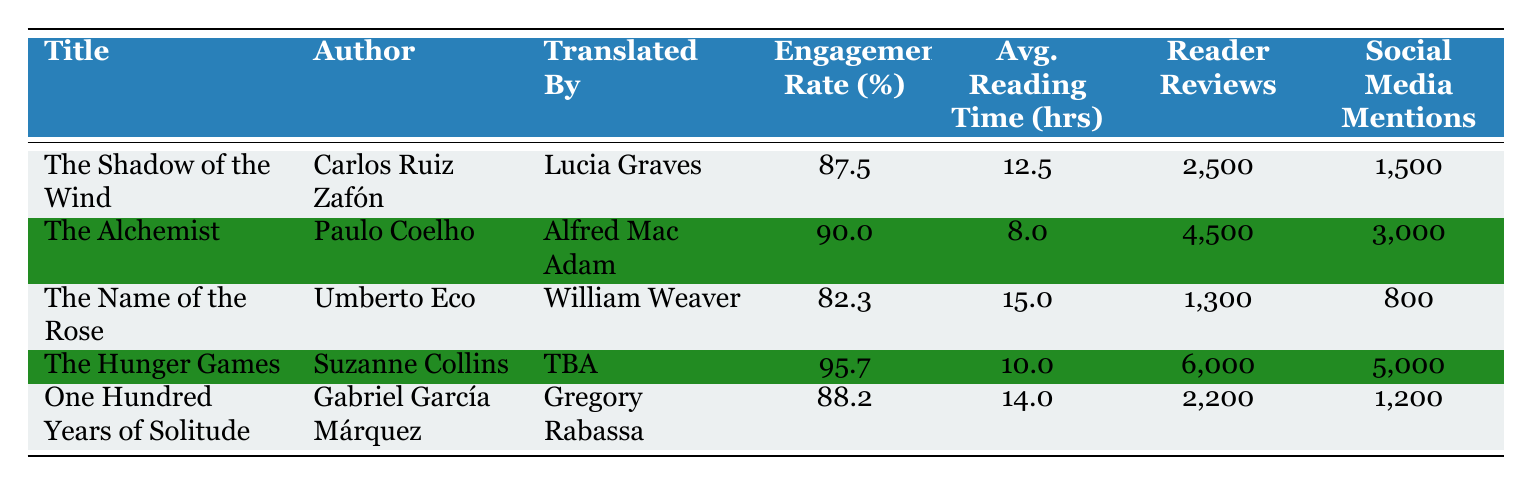What is the engagement rate of "The Hunger Games"? The table lists "The Hunger Games" with an engagement rate of 95.7%.
Answer: 95.7 Who translated "One Hundred Years of Solitude"? The table shows that "One Hundred Years of Solitude" was translated by Gregory Rabassa.
Answer: Gregory Rabassa Which book has the highest reader reviews count? By comparing the "Reader Reviews" column, "The Hunger Games" has the highest count at 6000.
Answer: The Hunger Games What is the average reading time of the books listed in the table? To find the average reading time, sum the reading times: 12.5 + 8.0 + 15.0 + 10.0 + 14.0 = 59.5 hours. Then divide by the number of books (5): 59.5 / 5 = 11.9 hours.
Answer: 11.9 hours Is the engagement rate of "The Name of the Rose" higher than that of "The Shadow of the Wind"? The engagement rate for "The Name of the Rose" is 82.3%, and for "The Shadow of the Wind," it is 87.5%. Since 82.3% is less than 87.5%, the statement is false.
Answer: No What is the percentage difference in engagement rates between "The Alchemist" and "The Shadow of the Wind"? The engagement rate of "The Alchemist" is 90.0% and for "The Shadow of the Wind" is 87.5%. The difference is 90.0 - 87.5 = 2.5%.
Answer: 2.5% Which author has the lowest engagement rate among the listed books? By checking the engagement rates, "The Name of the Rose" has the lowest at 82.3%.
Answer: Umberto Eco Calculate the total number of social media mentions across all books. Adding the social media mentions: 1500 + 3000 + 800 + 5000 + 1200 = 11000 mentions.
Answer: 11000 Has "The Hunger Games" received more social media mentions compared to "The Alchemist"? "The Hunger Games" received 5000 mentions while "The Alchemist" received 3000. Since 5000 > 3000, the statement is true.
Answer: Yes 